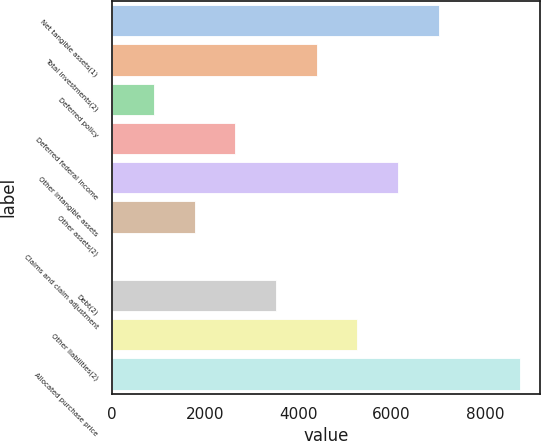<chart> <loc_0><loc_0><loc_500><loc_500><bar_chart><fcel>Net tangible assets(1)<fcel>Total investments(2)<fcel>Deferred policy<fcel>Deferred federal income<fcel>Other intangible assets<fcel>Other assets(2)<fcel>Claims and claim adjustment<fcel>Debt(2)<fcel>Other liabilities(2)<fcel>Allocated purchase price<nl><fcel>7010<fcel>4391<fcel>899<fcel>2645<fcel>6137<fcel>1772<fcel>26<fcel>3518<fcel>5264<fcel>8756<nl></chart> 